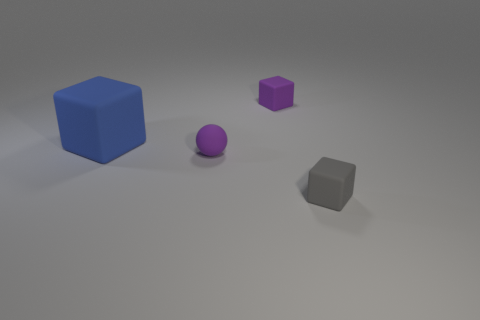How do the sizes of the objects compare to each other? From largest to smallest, the blue cube is the largest, followed by the gray object and the purple cube, with the purple ball being approximately the same size as the gray object but slightly smaller in diameter than the purple cube. Could you estimate their size if you assume the floor tiles are a standard size? Assuming the floor tiles are of a standard size, which might be around one foot square, the blue cube could measure roughly two feet on each side, the gray object and the purple ball could have a diameter of about six inches, and the purple cube could be approximately a one-foot cube. 